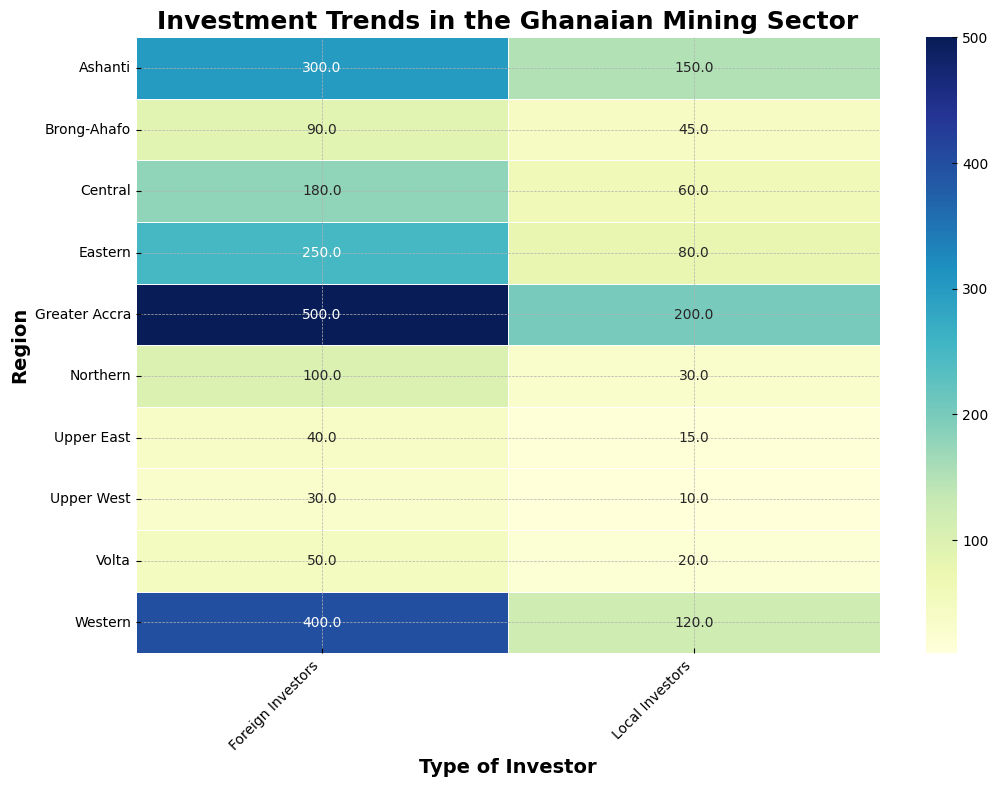Which region received the highest total investment from both local and foreign investors combined? To find the region with the highest total investment, add the investments from local and foreign investors for each region and compare the sums. Greater Accra got 200 (Local) + 500 (Foreign) = 700, which is the highest.
Answer: Greater Accra How does the investment from local investors in Ashanti compare to the investment from local investors in Volta? From the heatmap, local investors in Ashanti invested 150 million USD, while in Volta they invested 20 million USD. Comparing them, investment in Ashanti is significantly higher than in Volta.
Answer: Ashanti has much higher local investment What is the difference in foreign investment between the Western and Central regions? To find the difference, subtract the foreign investment in the Central region from that in the Western region: 400 (Western) - 180 (Central) = 220 million USD.
Answer: 220 million USD higher in the Western region Which type of investor contributed more in the Northern region, and by how much? Compare the investments in the Northern region from local (30 million USD) and foreign (100 million USD) investors, then find the difference: 100 - 30 = 70 million USD. Foreign investors contributed more.
Answer: Foreign investors by 70 million USD What is the average investment by local investors across all regions? Sum up all the local investments and divide by the number of regions: (150+120+80+60+30+45+20+15+10+200)/10 = 73 million USD.
Answer: 73 million USD Which region has the lowest total investment from foreign investors? By looking at the heatmap, the region with the lowest foreign investment is Upper West with 30 million USD.
Answer: Upper West Is the total investment in the Greater Accra region higher than the combined total investments of the Central and Brong-Ahafo regions? Sum up the investments in Central and Brong-Ahafo (Local + Foreign): (60+180) + (45+90) = 375 million USD. Compare this with Greater Accra's total of 700 million USD. Yes, Greater Accra’s total is higher.
Answer: Yes Which regions have local investments that are higher than foreign investments in any region? Identify local investments higher than any foreign investment: the highest foreign investment is 500 million USD. No region has local investments higher than this value, so the answer is none.
Answer: None 